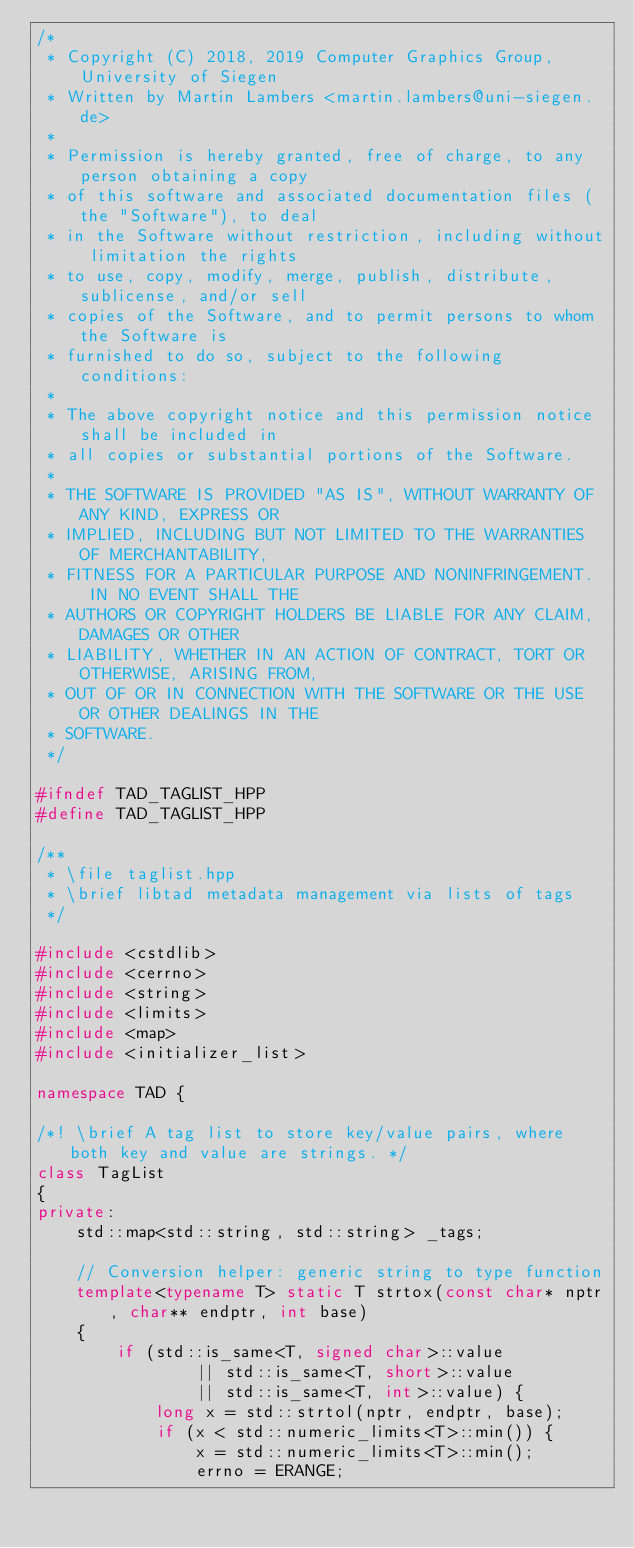<code> <loc_0><loc_0><loc_500><loc_500><_C++_>/*
 * Copyright (C) 2018, 2019 Computer Graphics Group, University of Siegen
 * Written by Martin Lambers <martin.lambers@uni-siegen.de>
 *
 * Permission is hereby granted, free of charge, to any person obtaining a copy
 * of this software and associated documentation files (the "Software"), to deal
 * in the Software without restriction, including without limitation the rights
 * to use, copy, modify, merge, publish, distribute, sublicense, and/or sell
 * copies of the Software, and to permit persons to whom the Software is
 * furnished to do so, subject to the following conditions:
 *
 * The above copyright notice and this permission notice shall be included in
 * all copies or substantial portions of the Software.
 *
 * THE SOFTWARE IS PROVIDED "AS IS", WITHOUT WARRANTY OF ANY KIND, EXPRESS OR
 * IMPLIED, INCLUDING BUT NOT LIMITED TO THE WARRANTIES OF MERCHANTABILITY,
 * FITNESS FOR A PARTICULAR PURPOSE AND NONINFRINGEMENT.  IN NO EVENT SHALL THE
 * AUTHORS OR COPYRIGHT HOLDERS BE LIABLE FOR ANY CLAIM, DAMAGES OR OTHER
 * LIABILITY, WHETHER IN AN ACTION OF CONTRACT, TORT OR OTHERWISE, ARISING FROM,
 * OUT OF OR IN CONNECTION WITH THE SOFTWARE OR THE USE OR OTHER DEALINGS IN THE
 * SOFTWARE.
 */

#ifndef TAD_TAGLIST_HPP
#define TAD_TAGLIST_HPP

/**
 * \file taglist.hpp
 * \brief libtad metadata management via lists of tags
 */

#include <cstdlib>
#include <cerrno>
#include <string>
#include <limits>
#include <map>
#include <initializer_list>

namespace TAD {

/*! \brief A tag list to store key/value pairs, where both key and value are strings. */
class TagList
{
private:
    std::map<std::string, std::string> _tags;

    // Conversion helper: generic string to type function
    template<typename T> static T strtox(const char* nptr, char** endptr, int base)
    {
        if (std::is_same<T, signed char>::value
                || std::is_same<T, short>::value
                || std::is_same<T, int>::value) {
            long x = std::strtol(nptr, endptr, base);
            if (x < std::numeric_limits<T>::min()) {
                x = std::numeric_limits<T>::min();
                errno = ERANGE;</code> 